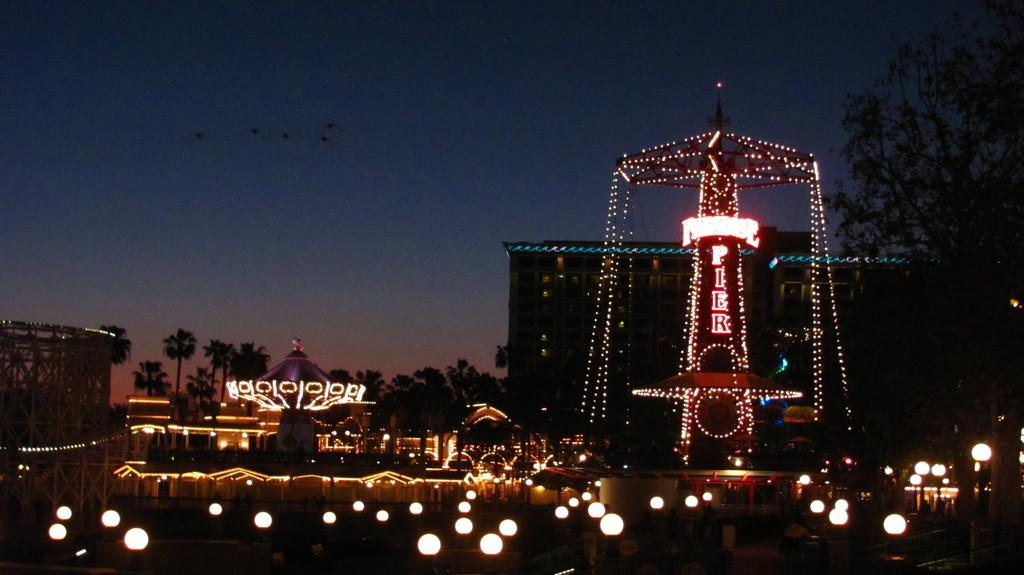What type of lighting arrangement can be seen in the image? There is a decorative lighting arrangement in the image. What structure is visible in the image? There is a building visible in the image. What type of vegetation is present in the image? There are trees in the image. What else is present in the image besides the lighting arrangement and trees? Lights are present in the image. What can be seen in the background of the image? The sky is visible in the image. Can you tell me how many monkeys are sitting on the building in the image? There are no monkeys present in the image; it features a decorative lighting arrangement, a building, trees, lights, and the sky. 